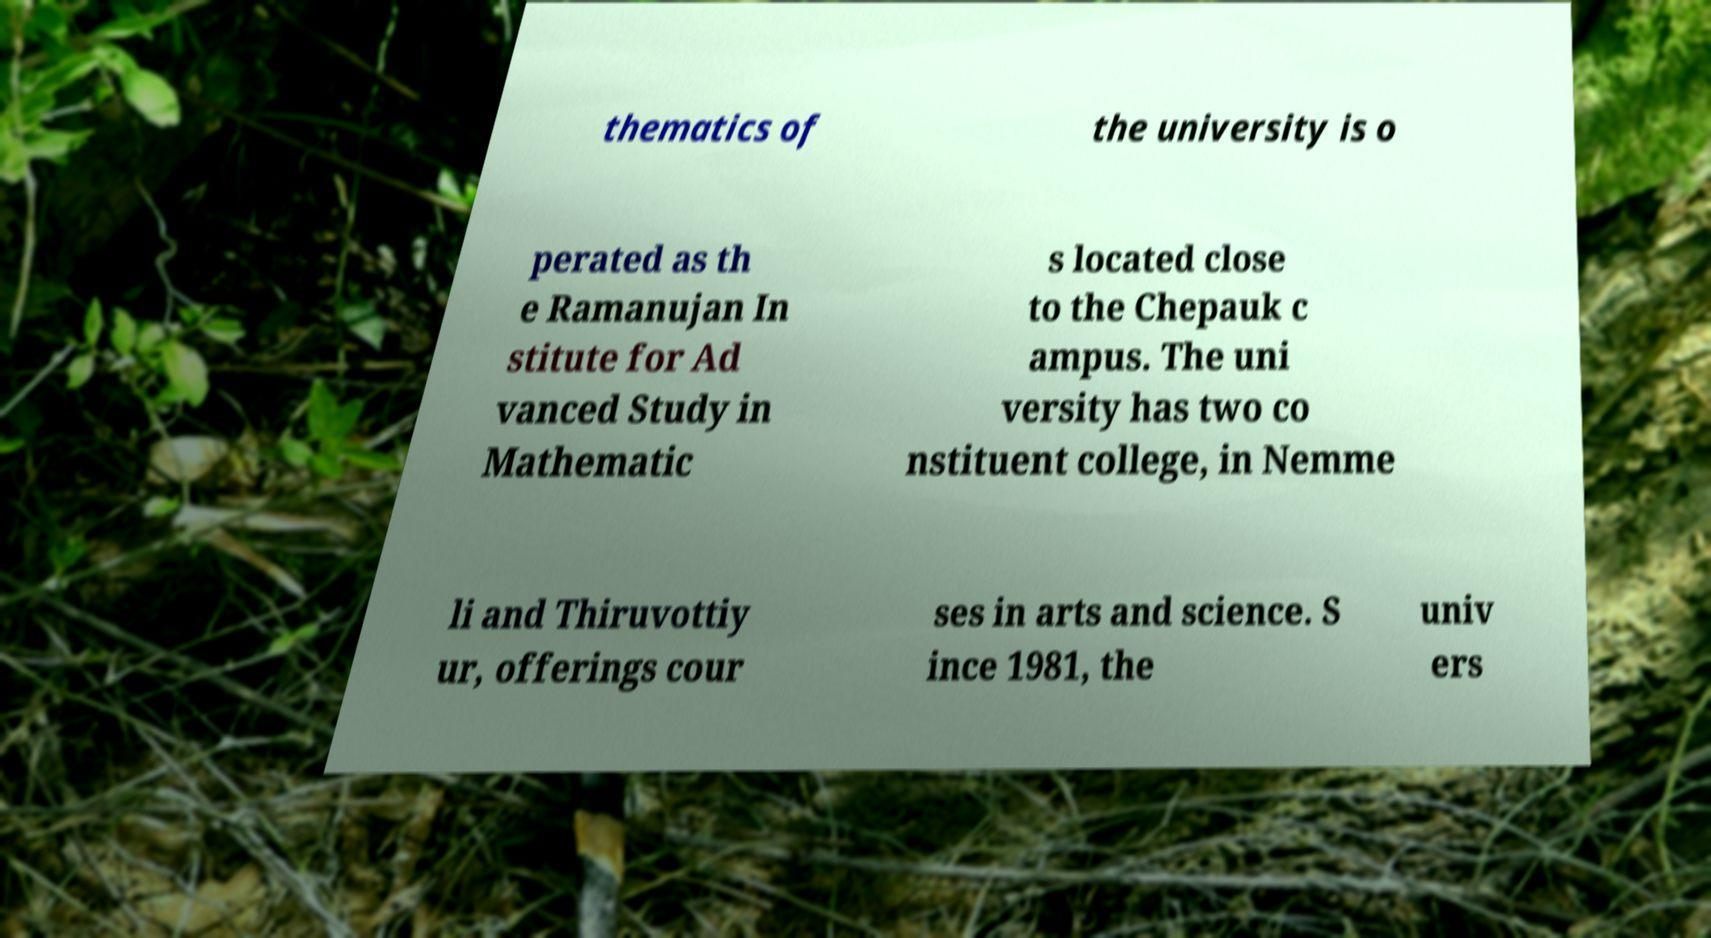I need the written content from this picture converted into text. Can you do that? thematics of the university is o perated as th e Ramanujan In stitute for Ad vanced Study in Mathematic s located close to the Chepauk c ampus. The uni versity has two co nstituent college, in Nemme li and Thiruvottiy ur, offerings cour ses in arts and science. S ince 1981, the univ ers 